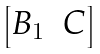Convert formula to latex. <formula><loc_0><loc_0><loc_500><loc_500>\begin{bmatrix} B _ { 1 } & C \end{bmatrix}</formula> 